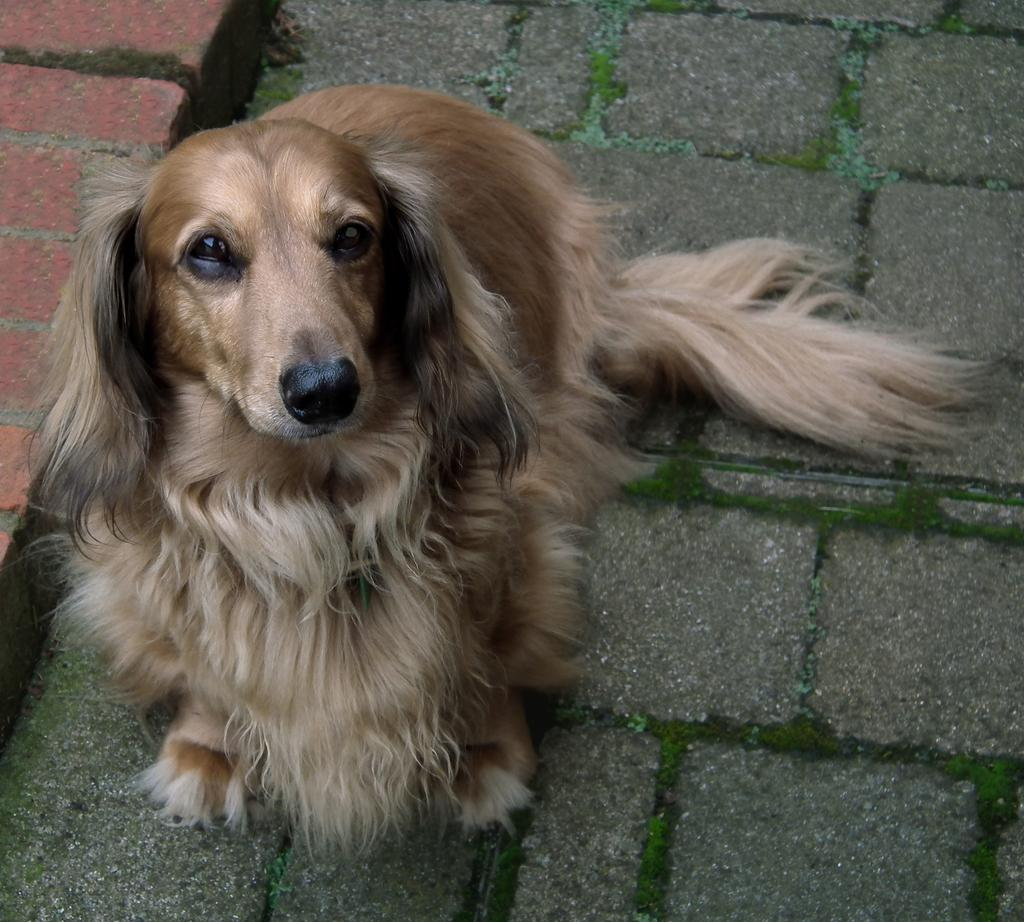What type of animal is present in the image? There is a dog in the image. Where is the dog located? The dog is on the floor. What can be seen in the background of the image? There is a bricks platform in the background of the image. How many clouds can be seen in the image? There are no clouds present in the image; it features a dog on the floor and a bricks platform in the background. 